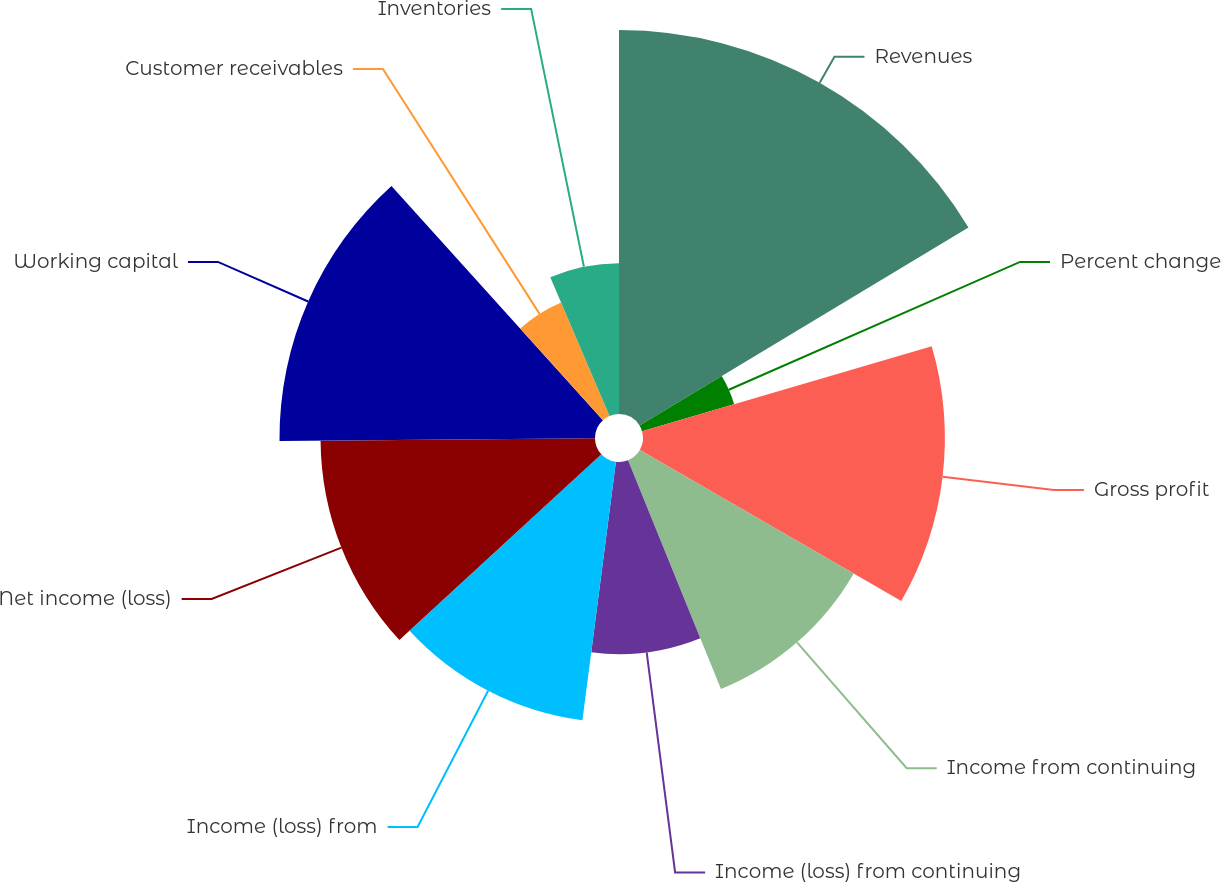<chart> <loc_0><loc_0><loc_500><loc_500><pie_chart><fcel>Revenues<fcel>Percent change<fcel>Gross profit<fcel>Income from continuing<fcel>Income (loss) from continuing<fcel>Income (loss) from<fcel>Net income (loss)<fcel>Working capital<fcel>Customer receivables<fcel>Inventories<nl><fcel>16.37%<fcel>4.09%<fcel>12.87%<fcel>10.53%<fcel>8.19%<fcel>11.11%<fcel>11.7%<fcel>13.45%<fcel>5.26%<fcel>6.43%<nl></chart> 